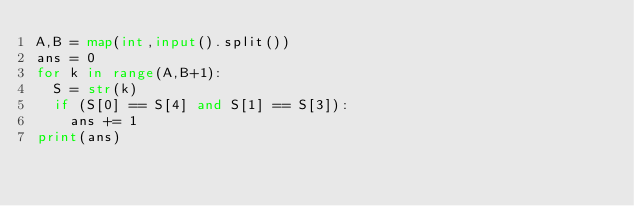<code> <loc_0><loc_0><loc_500><loc_500><_Python_>A,B = map(int,input().split())
ans = 0
for k in range(A,B+1):
  S = str(k)
  if (S[0] == S[4] and S[1] == S[3]):
    ans += 1
print(ans)</code> 